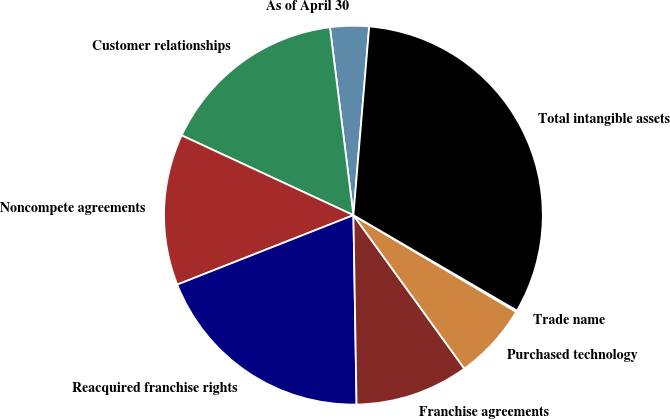Convert chart. <chart><loc_0><loc_0><loc_500><loc_500><pie_chart><fcel>As of April 30<fcel>Customer relationships<fcel>Noncompete agreements<fcel>Reacquired franchise rights<fcel>Franchise agreements<fcel>Purchased technology<fcel>Trade name<fcel>Total intangible assets<nl><fcel>3.31%<fcel>16.1%<fcel>12.9%<fcel>19.29%<fcel>9.7%<fcel>6.51%<fcel>0.12%<fcel>32.08%<nl></chart> 